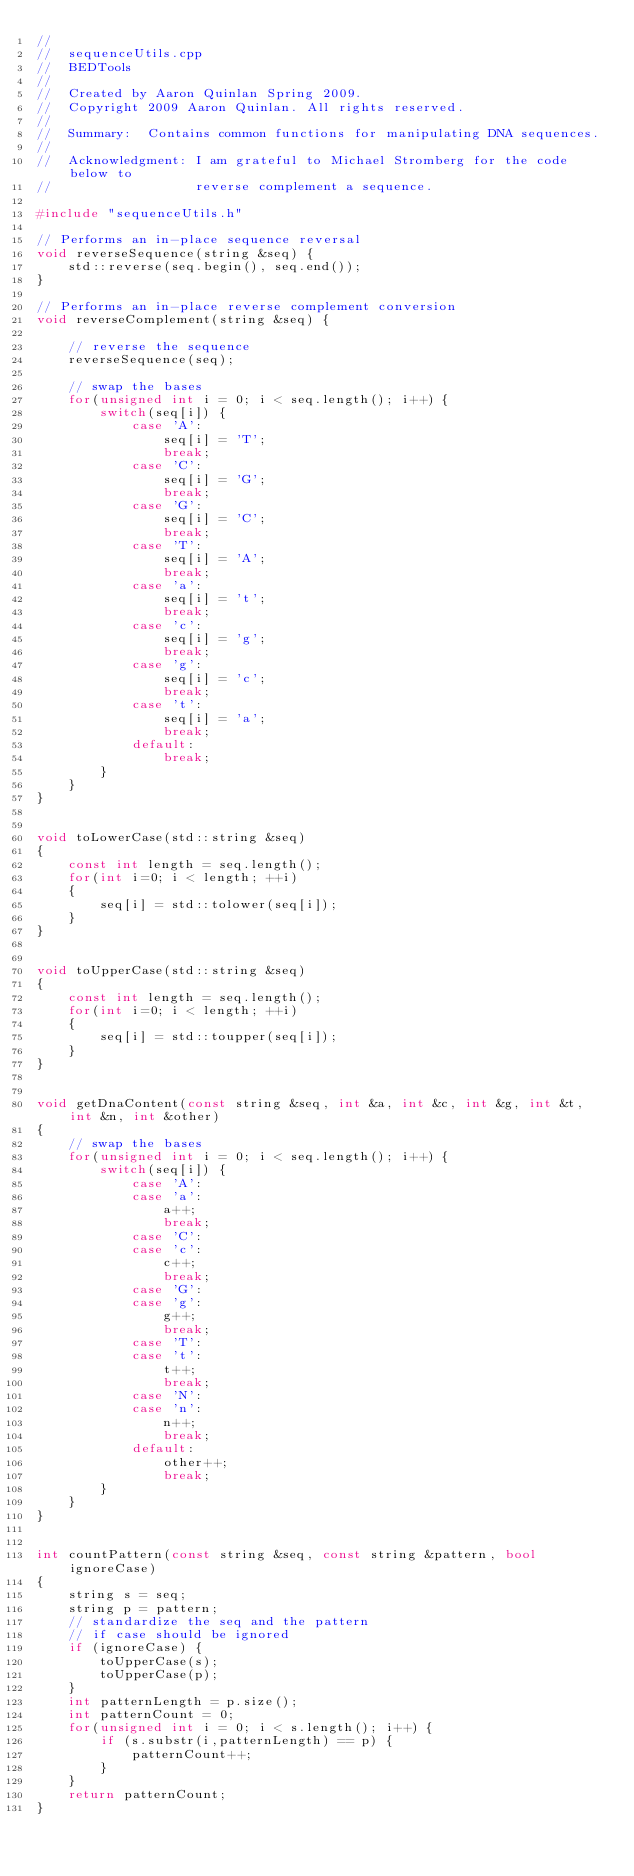<code> <loc_0><loc_0><loc_500><loc_500><_C++_>//
//  sequenceUtils.cpp
//  BEDTools
//
//  Created by Aaron Quinlan Spring 2009.
//  Copyright 2009 Aaron Quinlan. All rights reserved.
//
//  Summary:  Contains common functions for manipulating DNA sequences.
//
//  Acknowledgment: I am grateful to Michael Stromberg for the code below to
//                  reverse complement a sequence.

#include "sequenceUtils.h"

// Performs an in-place sequence reversal
void reverseSequence(string &seq) {
    std::reverse(seq.begin(), seq.end());
}

// Performs an in-place reverse complement conversion
void reverseComplement(string &seq) {

    // reverse the sequence
    reverseSequence(seq);

    // swap the bases
    for(unsigned int i = 0; i < seq.length(); i++) {
        switch(seq[i]) {
            case 'A':
                seq[i] = 'T';
                break;
            case 'C':
                seq[i] = 'G';
                break;
            case 'G':
                seq[i] = 'C';
                break;
            case 'T':
                seq[i] = 'A';
                break;
            case 'a':
                seq[i] = 't';
                break;
            case 'c':
                seq[i] = 'g';
                break;
            case 'g':
                seq[i] = 'c';
                break;
            case 't':
                seq[i] = 'a';
                break;
            default:
                break;
        }
    }
}


void toLowerCase(std::string &seq)
{
    const int length = seq.length();
    for(int i=0; i < length; ++i)
    {
        seq[i] = std::tolower(seq[i]);
    }
}


void toUpperCase(std::string &seq)
{
    const int length = seq.length();
    for(int i=0; i < length; ++i)
    {
        seq[i] = std::toupper(seq[i]);
    }
}


void getDnaContent(const string &seq, int &a, int &c, int &g, int &t, int &n, int &other)
{
    // swap the bases
    for(unsigned int i = 0; i < seq.length(); i++) {
        switch(seq[i]) {
            case 'A':
            case 'a':
                a++;
                break;
            case 'C':
            case 'c':
                c++;
                break;
            case 'G':
            case 'g':
                g++;
                break;
            case 'T':
            case 't':
                t++;
                break;
            case 'N':
            case 'n':
                n++;
                break;
            default:
                other++;
                break;
        }
    }    
}


int countPattern(const string &seq, const string &pattern, bool ignoreCase)
{
    string s = seq;
    string p = pattern;
    // standardize the seq and the pattern 
    // if case should be ignored
    if (ignoreCase) {
        toUpperCase(s);
        toUpperCase(p);
    }
    int patternLength = p.size();
    int patternCount = 0;
    for(unsigned int i = 0; i < s.length(); i++) {
        if (s.substr(i,patternLength) == p) {
            patternCount++;
        }
    }
    return patternCount;
}


</code> 